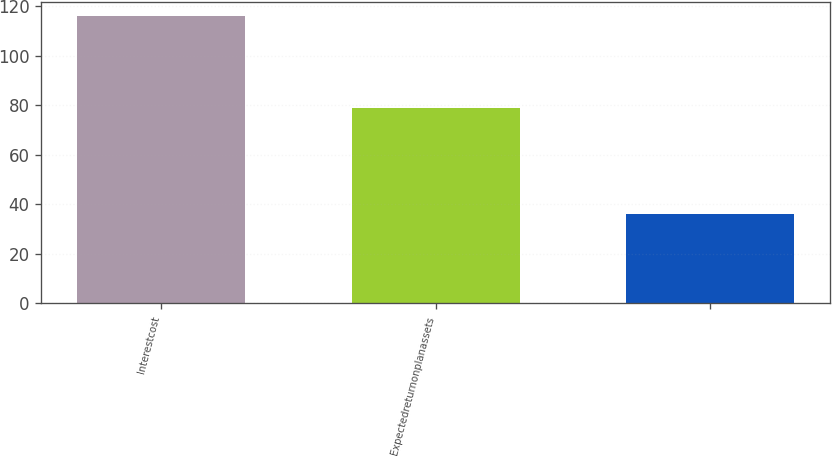Convert chart. <chart><loc_0><loc_0><loc_500><loc_500><bar_chart><fcel>Interestcost<fcel>Expectedreturnonplanassets<fcel>Unnamed: 2<nl><fcel>116<fcel>79<fcel>36<nl></chart> 